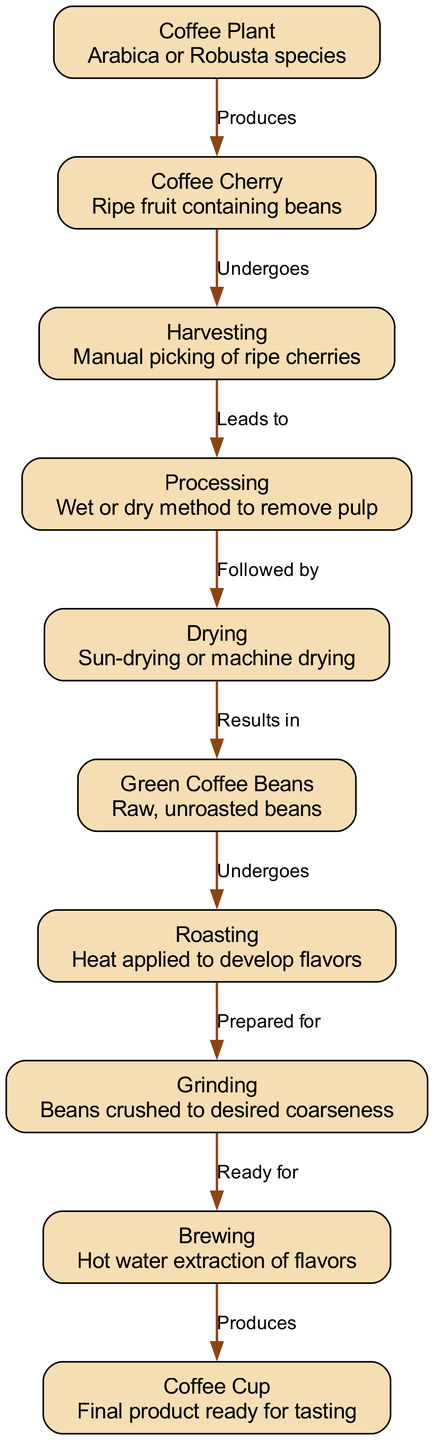What is the first step in the coffee bean life cycle? The diagram shows that the coffee cycle begins with the "Coffee Plant." This is indicated as the starting node with an edge pointing to the "Coffee Cherry."
Answer: Coffee Plant How many nodes are in the diagram? By counting the distinct entities represented in the diagram, there are a total of ten nodes that describe each stage in the life cycle.
Answer: Ten What process follows harvesting in the coffee bean life cycle? The flow of the diagram shows an edge leading from "Harvesting" to "Processing,” indicating that processing comes directly after harvesting.
Answer: Processing What is produced from brewing? According to the diagram, the final outcome of the brewing process is directed towards the "Coffee Cup," confirming that brewing produces the final product.
Answer: Coffee Cup Which type of coffee plant is mentioned in the diagram? The diagram specifies the coffee species as "Arabica or Robusta" in the description of the "Coffee Plant.”
Answer: Arabica or Robusta How many edges connect the nodes in the diagram? By analyzing the connections between the nodes, the diagram contains nine edges that represent relationships between the stages of the coffee life cycle.
Answer: Nine What occurs after green coffee beans are processed? Based on the diagram's flow, "Green Coffee Beans" lead into the "Roasting" phase following processing, indicating roasting occurs next.
Answer: Roasting Which stage involves the removal of pulp? The diagram indicates that the "Processing” stage involves methods to remove pulp from the coffee cherries, detailing what happens during that phase.
Answer: Processing What type of drying methods are mentioned in the diagram? The diagram explains that the "Drying" phase can use either "Sun-drying or machine drying," providing options for the drying methods used.
Answer: Sun-drying or machine drying 